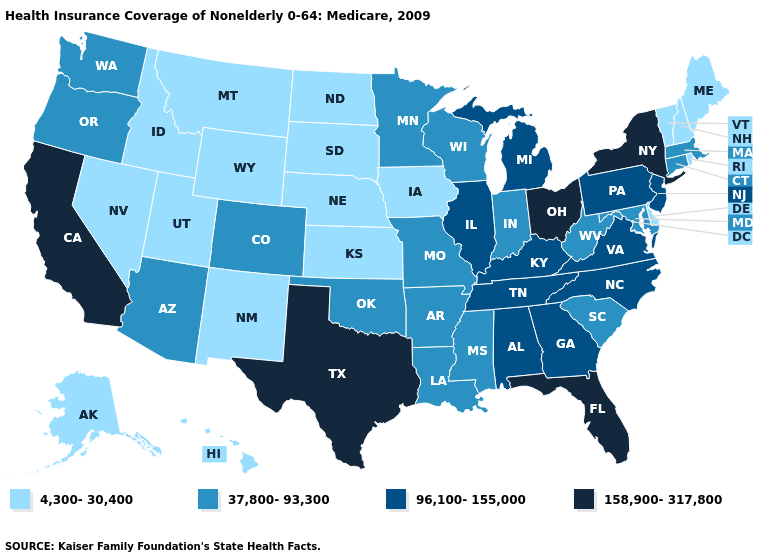Which states have the highest value in the USA?
Short answer required. California, Florida, New York, Ohio, Texas. Which states have the highest value in the USA?
Be succinct. California, Florida, New York, Ohio, Texas. What is the lowest value in states that border Minnesota?
Give a very brief answer. 4,300-30,400. What is the lowest value in the Northeast?
Give a very brief answer. 4,300-30,400. Name the states that have a value in the range 158,900-317,800?
Give a very brief answer. California, Florida, New York, Ohio, Texas. Does Arizona have the lowest value in the West?
Quick response, please. No. Name the states that have a value in the range 37,800-93,300?
Be succinct. Arizona, Arkansas, Colorado, Connecticut, Indiana, Louisiana, Maryland, Massachusetts, Minnesota, Mississippi, Missouri, Oklahoma, Oregon, South Carolina, Washington, West Virginia, Wisconsin. What is the value of Ohio?
Concise answer only. 158,900-317,800. Does North Dakota have a higher value than New Hampshire?
Keep it brief. No. Does Iowa have the same value as Kansas?
Be succinct. Yes. What is the value of Arizona?
Write a very short answer. 37,800-93,300. What is the value of Hawaii?
Short answer required. 4,300-30,400. Name the states that have a value in the range 37,800-93,300?
Short answer required. Arizona, Arkansas, Colorado, Connecticut, Indiana, Louisiana, Maryland, Massachusetts, Minnesota, Mississippi, Missouri, Oklahoma, Oregon, South Carolina, Washington, West Virginia, Wisconsin. Name the states that have a value in the range 4,300-30,400?
Quick response, please. Alaska, Delaware, Hawaii, Idaho, Iowa, Kansas, Maine, Montana, Nebraska, Nevada, New Hampshire, New Mexico, North Dakota, Rhode Island, South Dakota, Utah, Vermont, Wyoming. Name the states that have a value in the range 4,300-30,400?
Give a very brief answer. Alaska, Delaware, Hawaii, Idaho, Iowa, Kansas, Maine, Montana, Nebraska, Nevada, New Hampshire, New Mexico, North Dakota, Rhode Island, South Dakota, Utah, Vermont, Wyoming. 